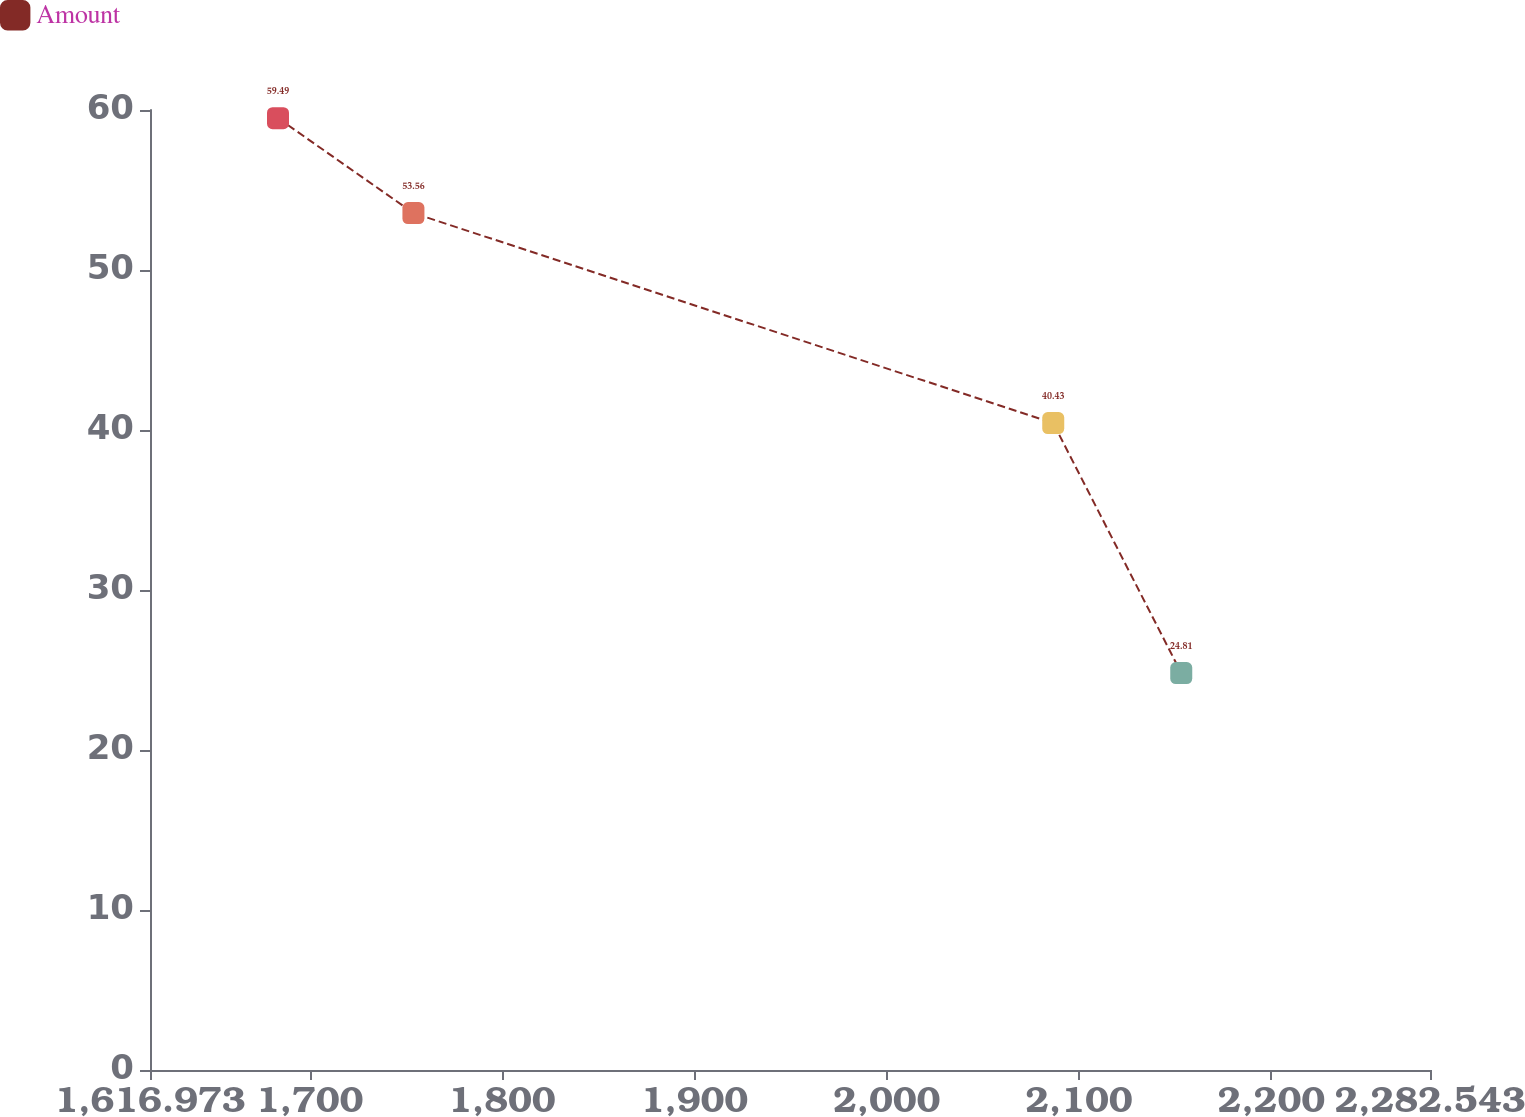Convert chart. <chart><loc_0><loc_0><loc_500><loc_500><line_chart><ecel><fcel>Amount<nl><fcel>1683.53<fcel>59.49<nl><fcel>1753.95<fcel>53.56<nl><fcel>2086.64<fcel>40.43<nl><fcel>2153.2<fcel>24.81<nl><fcel>2349.1<fcel>19.19<nl></chart> 